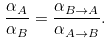<formula> <loc_0><loc_0><loc_500><loc_500>\frac { \alpha _ { A } } { \alpha _ { B } } = \frac { \alpha _ { B \rightarrow A } } { \alpha _ { A \rightarrow B } } .</formula> 